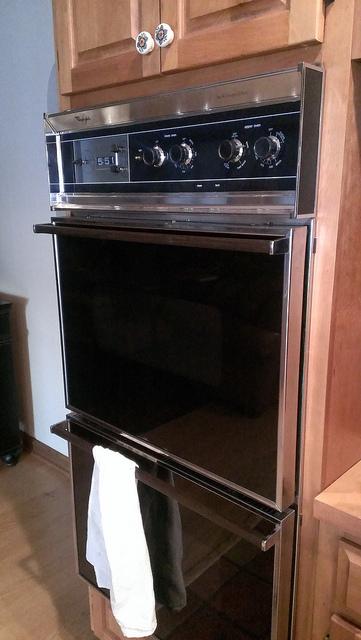Where is the white towel located?
Concise answer only. Oven. What color are the cabinets?
Short answer required. Brown. What is the bottom drawer of the stove used for?
Short answer required. Oven. 